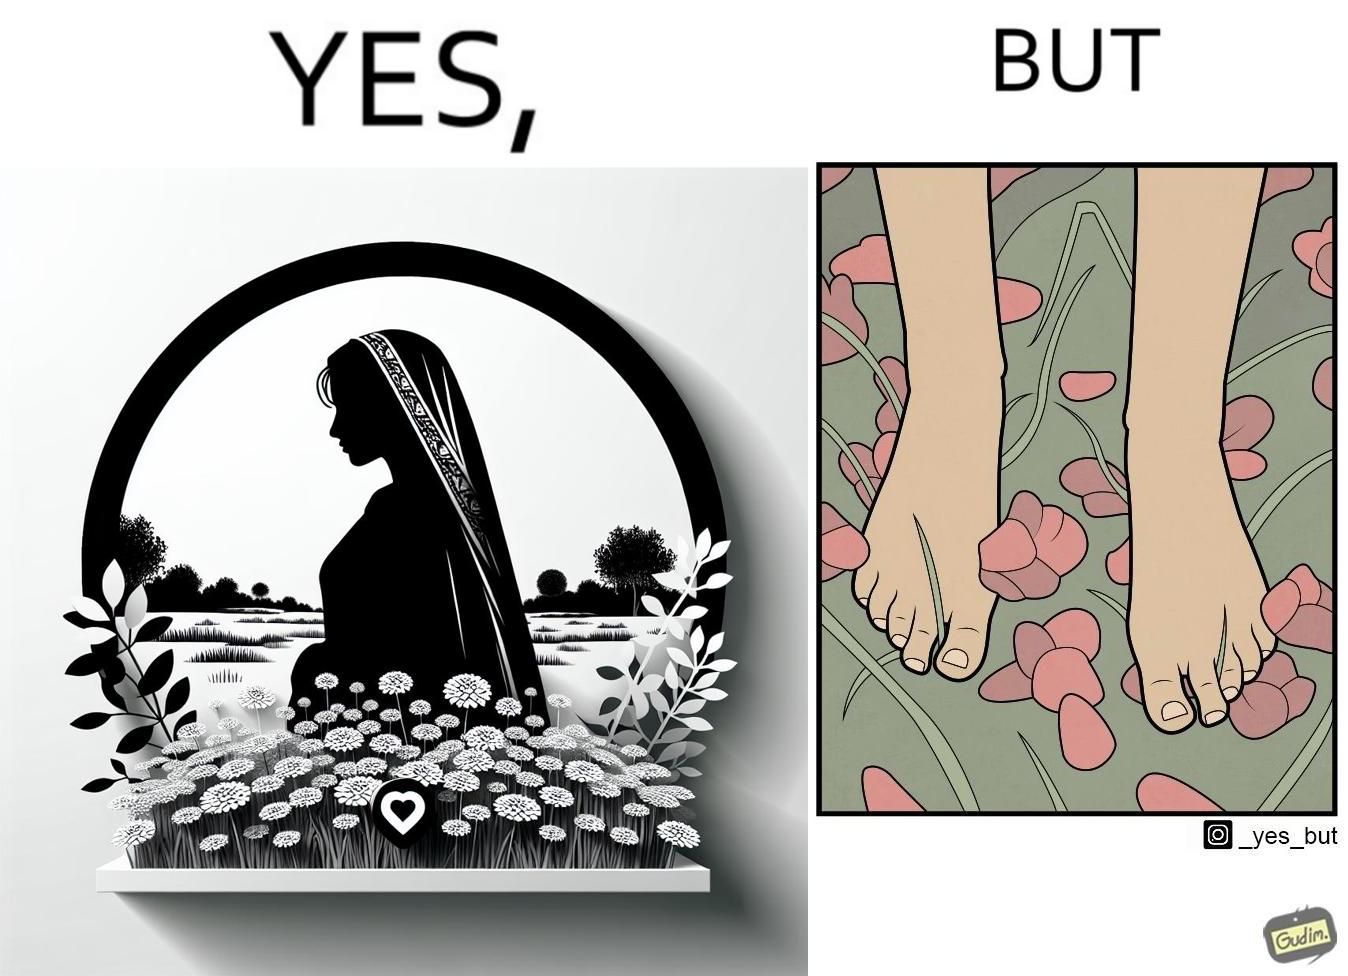What makes this image funny or satirical? The image is ironical, as the social ,edia post shows the appreciation of nature, while an image of the feet on the ground stepping on the flower petals shows an unintentional disrespect of nature. 